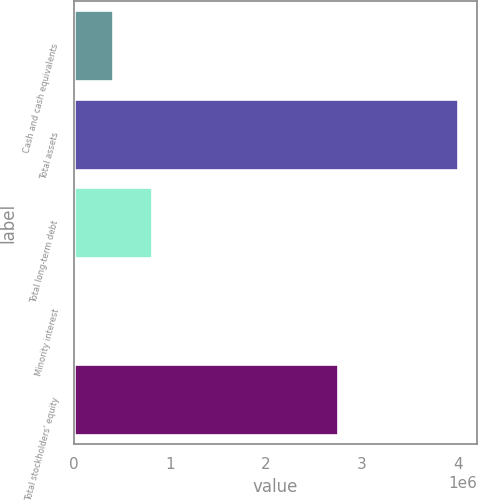Convert chart. <chart><loc_0><loc_0><loc_500><loc_500><bar_chart><fcel>Cash and cash equivalents<fcel>Total assets<fcel>Total long-term debt<fcel>Minority interest<fcel>Total stockholders' equity<nl><fcel>412539<fcel>4.00286e+06<fcel>811463<fcel>13615<fcel>2.75484e+06<nl></chart> 